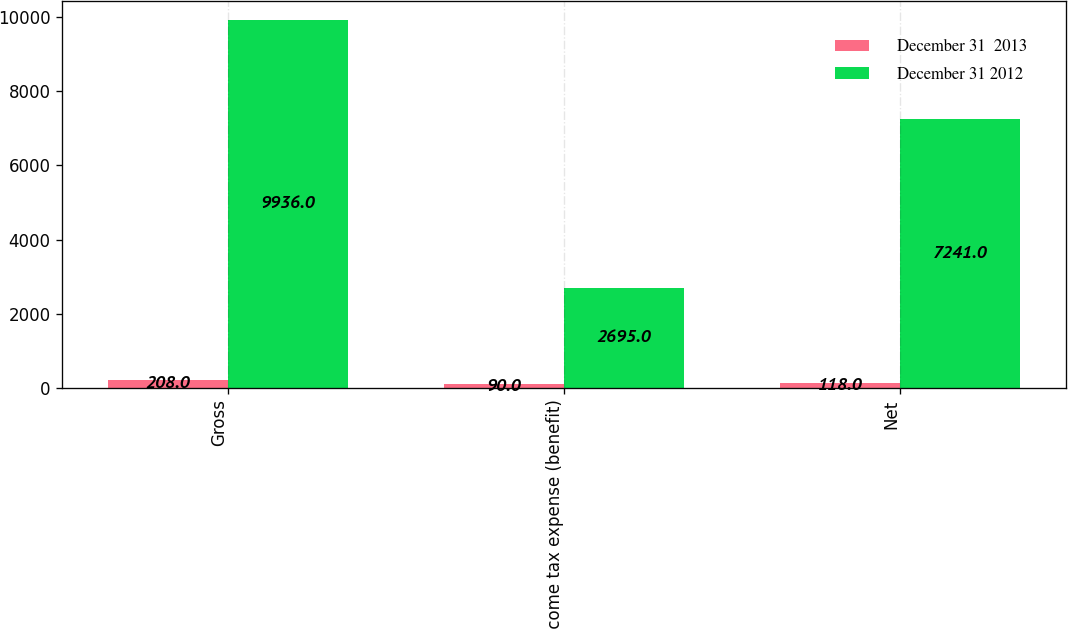Convert chart. <chart><loc_0><loc_0><loc_500><loc_500><stacked_bar_chart><ecel><fcel>Gross<fcel>Income tax expense (benefit)<fcel>Net<nl><fcel>December 31  2013<fcel>208<fcel>90<fcel>118<nl><fcel>December 31 2012<fcel>9936<fcel>2695<fcel>7241<nl></chart> 